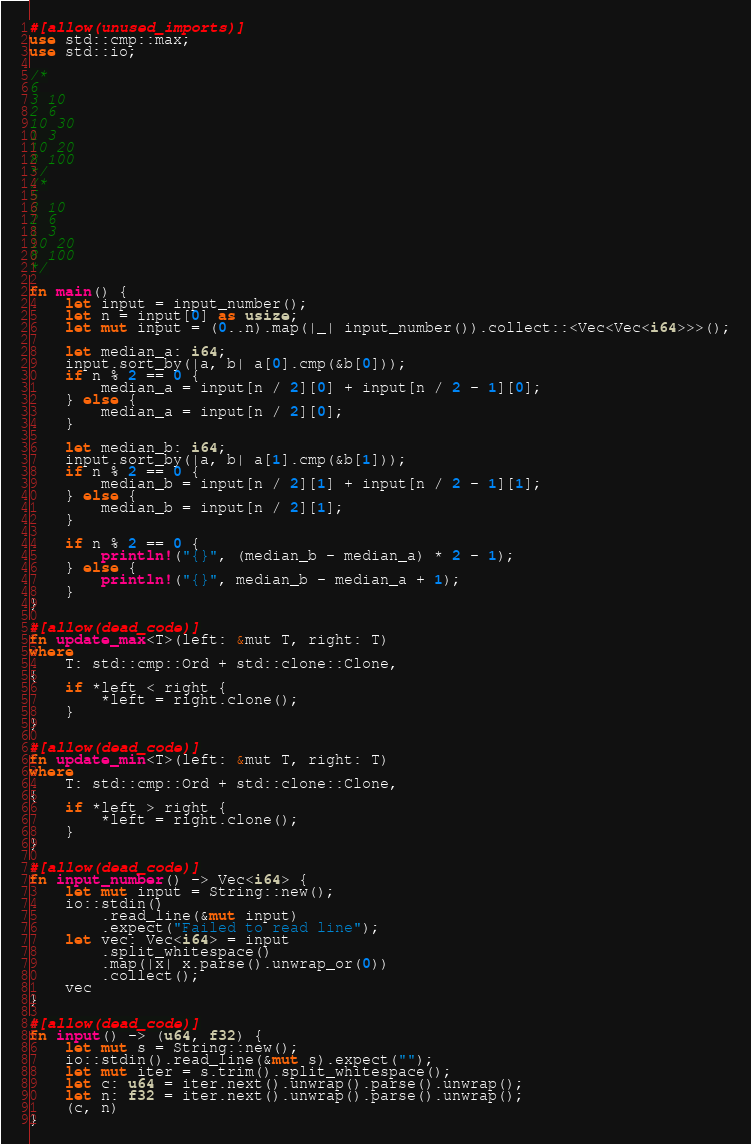<code> <loc_0><loc_0><loc_500><loc_500><_Rust_>#[allow(unused_imports)]
use std::cmp::max;
use std::io;

/*
6
3 10
2 6
10 30
1 3
10 20
8 100
*/
/*
5
3 10
2 6
1 3
10 20
8 100
*/

fn main() {
    let input = input_number();
    let n = input[0] as usize;
    let mut input = (0..n).map(|_| input_number()).collect::<Vec<Vec<i64>>>();

    let median_a: i64;
    input.sort_by(|a, b| a[0].cmp(&b[0]));
    if n % 2 == 0 {
        median_a = input[n / 2][0] + input[n / 2 - 1][0];
    } else {
        median_a = input[n / 2][0];
    }

    let median_b: i64;
    input.sort_by(|a, b| a[1].cmp(&b[1]));
    if n % 2 == 0 {
        median_b = input[n / 2][1] + input[n / 2 - 1][1];
    } else {
        median_b = input[n / 2][1];
    }

    if n % 2 == 0 {
        println!("{}", (median_b - median_a) * 2 - 1);
    } else {
        println!("{}", median_b - median_a + 1);
    }
}

#[allow(dead_code)]
fn update_max<T>(left: &mut T, right: T)
where
    T: std::cmp::Ord + std::clone::Clone,
{
    if *left < right {
        *left = right.clone();
    }
}

#[allow(dead_code)]
fn update_min<T>(left: &mut T, right: T)
where
    T: std::cmp::Ord + std::clone::Clone,
{
    if *left > right {
        *left = right.clone();
    }
}

#[allow(dead_code)]
fn input_number() -> Vec<i64> {
    let mut input = String::new();
    io::stdin()
        .read_line(&mut input)
        .expect("Failed to read line");
    let vec: Vec<i64> = input
        .split_whitespace()
        .map(|x| x.parse().unwrap_or(0))
        .collect();
    vec
}

#[allow(dead_code)]
fn input() -> (u64, f32) {
    let mut s = String::new();
    io::stdin().read_line(&mut s).expect("");
    let mut iter = s.trim().split_whitespace();
    let c: u64 = iter.next().unwrap().parse().unwrap();
    let n: f32 = iter.next().unwrap().parse().unwrap();
    (c, n)
}
</code> 